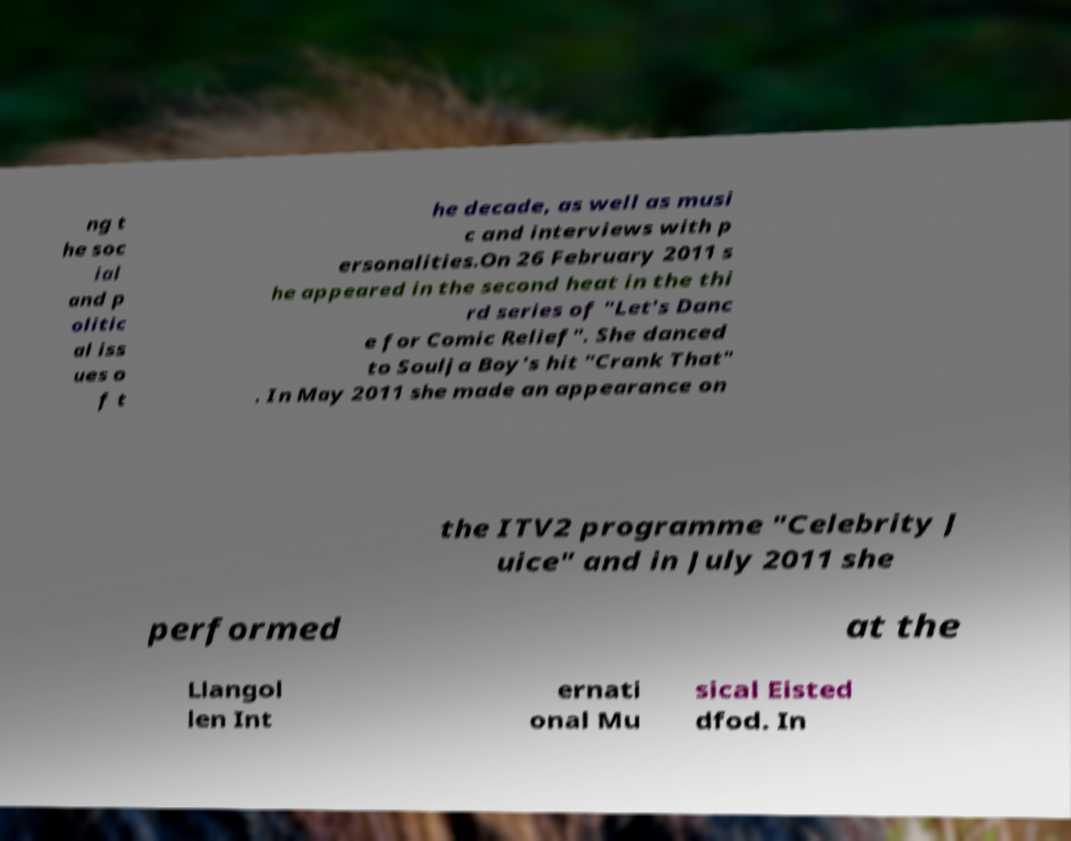What messages or text are displayed in this image? I need them in a readable, typed format. ng t he soc ial and p olitic al iss ues o f t he decade, as well as musi c and interviews with p ersonalities.On 26 February 2011 s he appeared in the second heat in the thi rd series of "Let's Danc e for Comic Relief". She danced to Soulja Boy's hit "Crank That" . In May 2011 she made an appearance on the ITV2 programme "Celebrity J uice" and in July 2011 she performed at the Llangol len Int ernati onal Mu sical Eisted dfod. In 